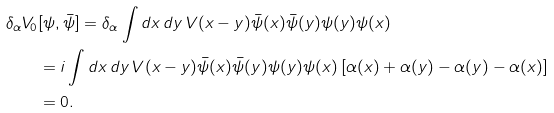<formula> <loc_0><loc_0><loc_500><loc_500>\delta _ { \alpha } V _ { 0 } & [ \psi , \bar { \psi } ] = \delta _ { \alpha } \int d x \, d y \, V ( x - y ) \bar { \psi } ( x ) \bar { \psi } ( y ) \psi ( y ) \psi ( x ) \\ & = i \int d x \, d y \, V ( x - y ) \bar { \psi } ( x ) \bar { \psi } ( y ) \psi ( y ) \psi ( x ) \, [ \alpha ( x ) + \alpha ( y ) - \alpha ( y ) - \alpha ( x ) ] \\ & = 0 .</formula> 